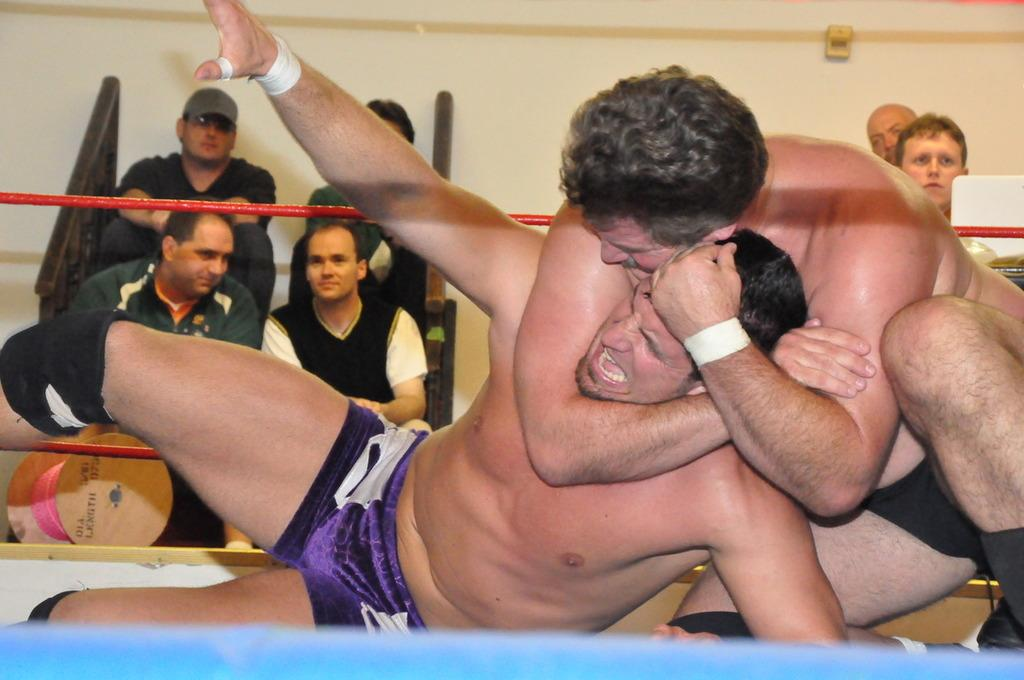How many people are in the image? There are two persons in the image. What are the two persons doing? The two persons are fighting with each other. Where is the fighting taking place? The fighting is taking place in a wrestling ring. Are there any other people visible in the image? Yes, there are spectators visible in the image. What type of flag is being waved by the spectators in the image? There is no flag visible in the image; the focus is on the wrestling match and the spectators. 